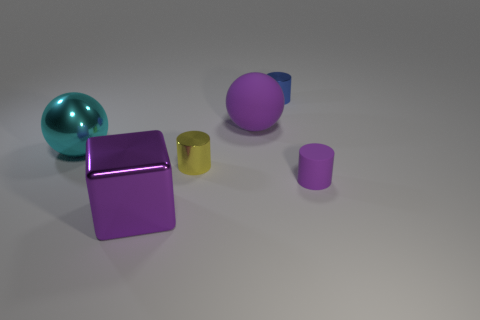Are there any small objects right of the small blue metallic cylinder?
Your answer should be very brief. Yes. Is the size of the yellow object the same as the purple metal cube?
Your response must be concise. No. There is a big metallic object right of the large cyan sphere; what shape is it?
Your answer should be compact. Cube. Is there a purple shiny block of the same size as the yellow metallic cylinder?
Offer a terse response. No. There is a purple thing that is the same size as the yellow object; what material is it?
Your response must be concise. Rubber. There is a metal thing in front of the yellow metallic thing; what is its size?
Your answer should be compact. Large. What size is the purple block?
Offer a very short reply. Large. Is the size of the purple cylinder the same as the metallic thing that is behind the large shiny sphere?
Keep it short and to the point. Yes. What is the color of the small object left of the purple matte thing that is behind the tiny purple matte cylinder?
Give a very brief answer. Yellow. Are there an equal number of purple cubes that are behind the small blue cylinder and blue things in front of the tiny yellow metallic object?
Offer a terse response. Yes. 